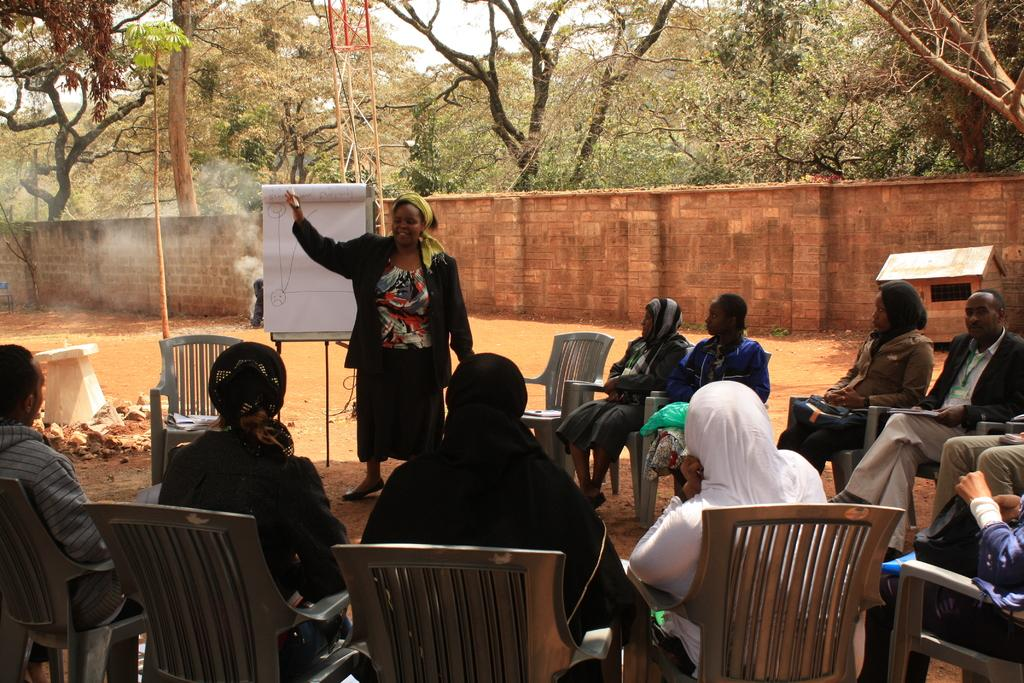What are the people in the image doing? There is a group of people sitting on chairs in the image. Is there anyone standing in the image? Yes, there is a person standing on the ground in the image. What can be seen on the ground in the image? There is a board in the image. How many chairs are visible in the image? There are empty chairs in the image. What type of natural elements can be seen in the image? There are trees in the image. What company do the people in the image work for? There is no information about the company the people in the image work for. How do the trees in the image sort themselves? The trees in the image do not sort themselves; they are stationary natural elements. 